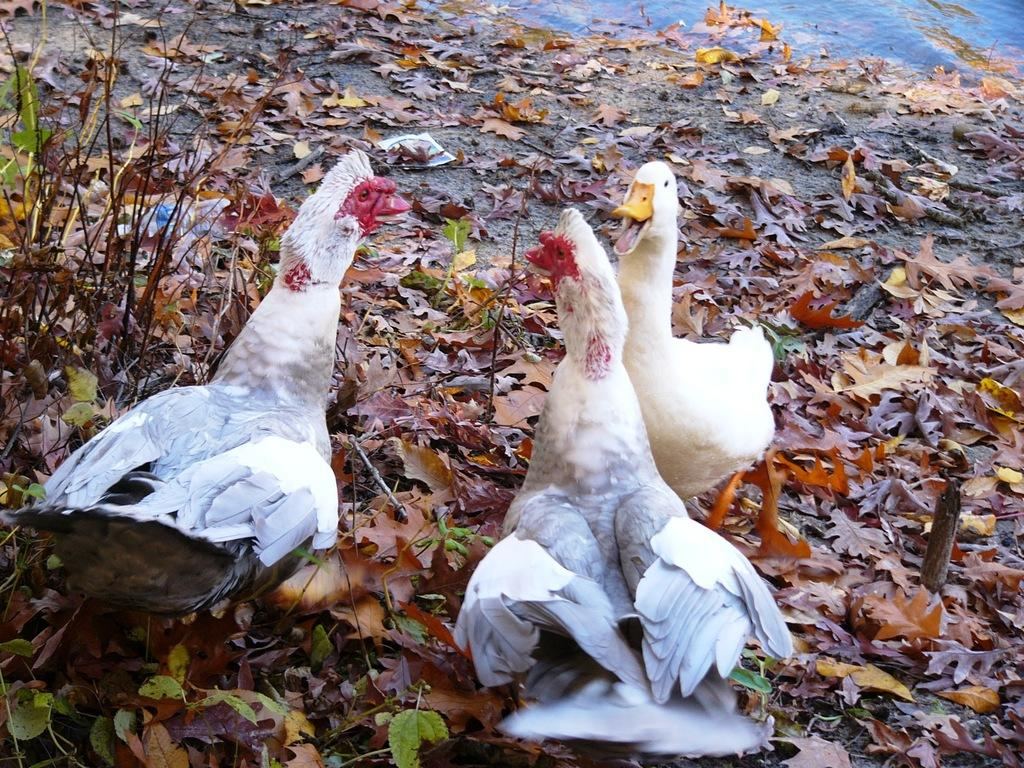What animals are in the center of the image? There are hens in the center of the image. What other animal can be seen in the center of the image? There is a bird on the ground in the center of the image. What can be seen in the background of the image? There are leaves and water visible in the background of the image. What type of surface is visible in the background of the image? The ground is visible in the background of the image. What is the weight of the nation depicted in the image? There is no nation depicted in the image, and therefore no weight can be assigned to it. 